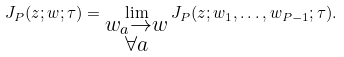<formula> <loc_0><loc_0><loc_500><loc_500>J _ { P } ( z ; w ; \tau ) = \lim _ { \substack { w _ { a } \to w \\ \forall a } } J _ { P } ( z ; w _ { 1 } , \dots , w _ { P - 1 } ; \tau ) .</formula> 